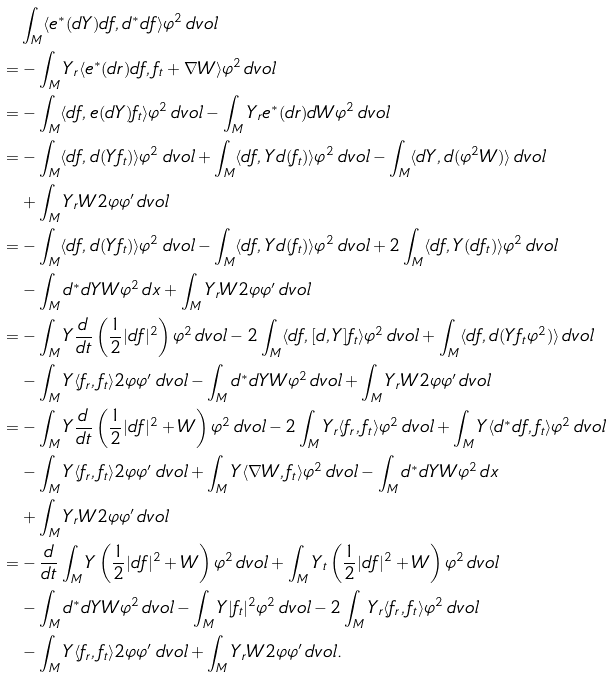<formula> <loc_0><loc_0><loc_500><loc_500>& \int _ { M } \langle e ^ { * } ( d Y ) d f , d ^ { * } d f \rangle \varphi ^ { 2 } \, d v o l \\ = & - \int _ { M } Y _ { r } \langle e ^ { * } ( d r ) d f , f _ { t } + \nabla W \rangle \varphi ^ { 2 } \, d v o l \\ = & - \int _ { M } \langle d f , e ( d Y ) f _ { t } \rangle \varphi ^ { 2 } \, d v o l - \int _ { M } Y _ { r } e ^ { * } ( d r ) d W \varphi ^ { 2 } \, d v o l \\ = & - \int _ { M } \langle d f , d ( Y f _ { t } ) \rangle \varphi ^ { 2 } \, d v o l + \int _ { M } \langle d f , Y d ( f _ { t } ) \rangle \varphi ^ { 2 } \, d v o l - \int _ { M } \langle d Y , d ( \varphi ^ { 2 } W ) \rangle \, d v o l \\ & + \int _ { M } Y _ { r } W 2 \varphi \varphi ^ { \prime } \, d v o l \\ = & - \int _ { M } \langle d f , d ( Y f _ { t } ) \rangle \varphi ^ { 2 } \, d v o l - \int _ { M } \langle d f , Y d ( f _ { t } ) \rangle \varphi ^ { 2 } \, d v o l + 2 \int _ { M } \langle d f , Y ( d f _ { t } ) \rangle \varphi ^ { 2 } \, d v o l \\ & - \int _ { M } d ^ { * } d Y W \varphi ^ { 2 } \, d x + \int _ { M } Y _ { r } W 2 \varphi \varphi ^ { \prime } \, d v o l \\ = & - \int _ { M } Y \frac { d } { d t } \left ( \frac { 1 } { 2 } | d f | ^ { 2 } \right ) \varphi ^ { 2 } \, d v o l - 2 \int _ { M } \langle d f , [ d , Y ] f _ { t } \rangle \varphi ^ { 2 } \, d v o l + \int _ { M } \langle d f , d ( Y f _ { t } \varphi ^ { 2 } ) \rangle \, d v o l \\ & - \int _ { M } Y \langle f _ { r } , f _ { t } \rangle 2 \varphi \varphi ^ { \prime } \, d v o l - \int _ { M } d ^ { * } d Y W \varphi ^ { 2 } \, d v o l + \int _ { M } Y _ { r } W 2 \varphi \varphi ^ { \prime } \, d v o l \\ = & - \int _ { M } Y \frac { d } { d t } \left ( \frac { 1 } { 2 } | d f | ^ { 2 } + W \right ) \varphi ^ { 2 } \, d v o l - 2 \int _ { M } Y _ { r } \langle f _ { r } , f _ { t } \rangle \varphi ^ { 2 } \, d v o l + \int _ { M } Y \langle d ^ { * } d f , f _ { t } \rangle \varphi ^ { 2 } \, d v o l \\ & - \int _ { M } Y \langle f _ { r } , f _ { t } \rangle 2 \varphi \varphi ^ { \prime } \, d v o l + \int _ { M } Y \langle \nabla W , f _ { t } \rangle \varphi ^ { 2 } \, d v o l - \int _ { M } d ^ { * } d Y W \varphi ^ { 2 } \, d x \\ & + \int _ { M } Y _ { r } W 2 \varphi \varphi ^ { \prime } \, d v o l \\ = & - \frac { d } { d t } \int _ { M } Y \left ( \frac { 1 } { 2 } | d f | ^ { 2 } + W \right ) \varphi ^ { 2 } \, d v o l + \int _ { M } Y _ { t } \left ( \frac { 1 } { 2 } | d f | ^ { 2 } + W \right ) \varphi ^ { 2 } \, d v o l \\ & - \int _ { M } d ^ { * } d Y W \varphi ^ { 2 } \, d v o l - \int _ { M } Y | f _ { t } | ^ { 2 } \varphi ^ { 2 } \, d v o l - 2 \int _ { M } Y _ { r } \langle f _ { r } , f _ { t } \rangle \varphi ^ { 2 } \, d v o l \\ & - \int _ { M } Y \langle f _ { r } , f _ { t } \rangle 2 \varphi \varphi ^ { \prime } \, d v o l + \int _ { M } Y _ { r } W 2 \varphi \varphi ^ { \prime } \, d v o l .</formula> 